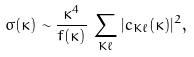Convert formula to latex. <formula><loc_0><loc_0><loc_500><loc_500>\sigma ( \kappa ) \sim \frac { \kappa ^ { 4 } } { f ( \kappa ) } \, \sum _ { K \ell } | c _ { K \ell } ( \kappa ) | ^ { 2 } ,</formula> 